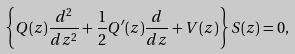Convert formula to latex. <formula><loc_0><loc_0><loc_500><loc_500>\left \{ Q ( z ) \frac { d ^ { 2 } } { d z ^ { 2 } } + \frac { 1 } { 2 } Q ^ { \prime } ( z ) \frac { d } { d z } + V ( z ) \right \} S ( z ) = 0 ,</formula> 